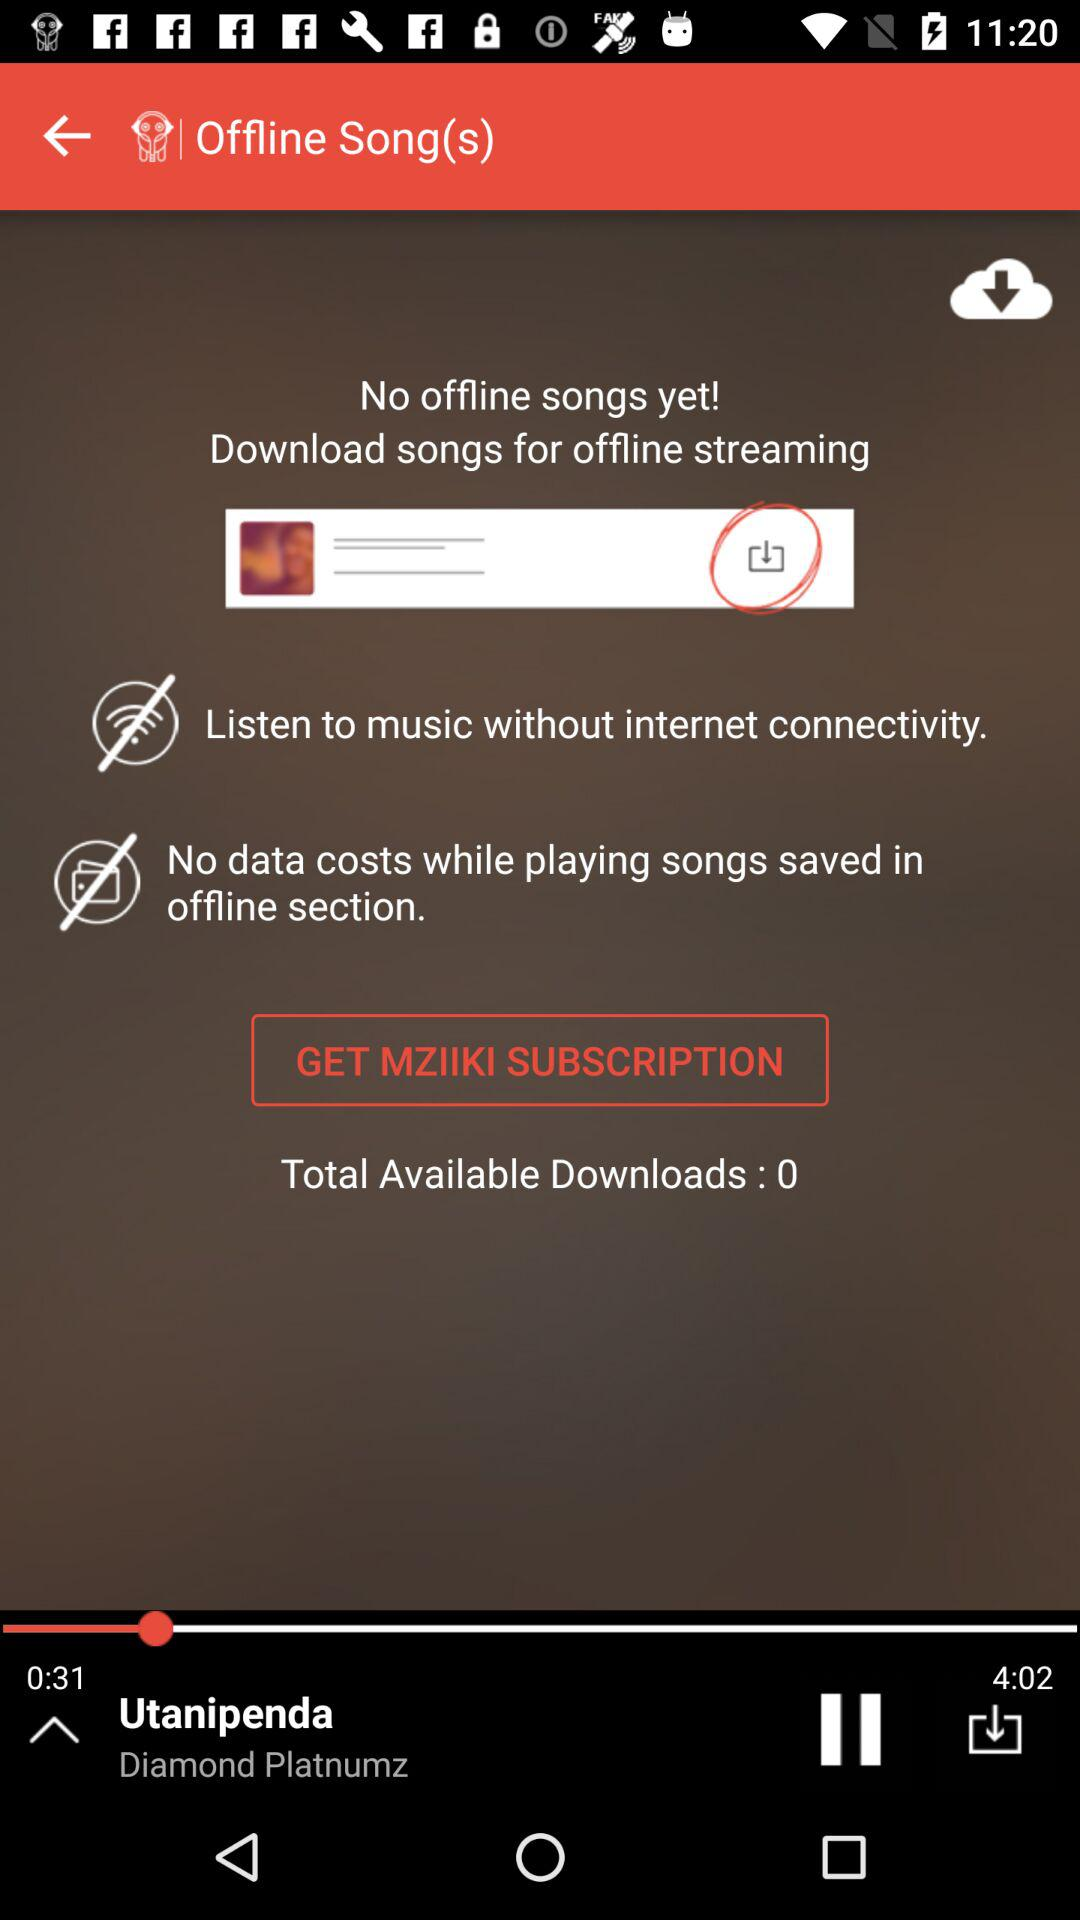What do we need to do for offline streaming? You need to download songs for offline streaming. 